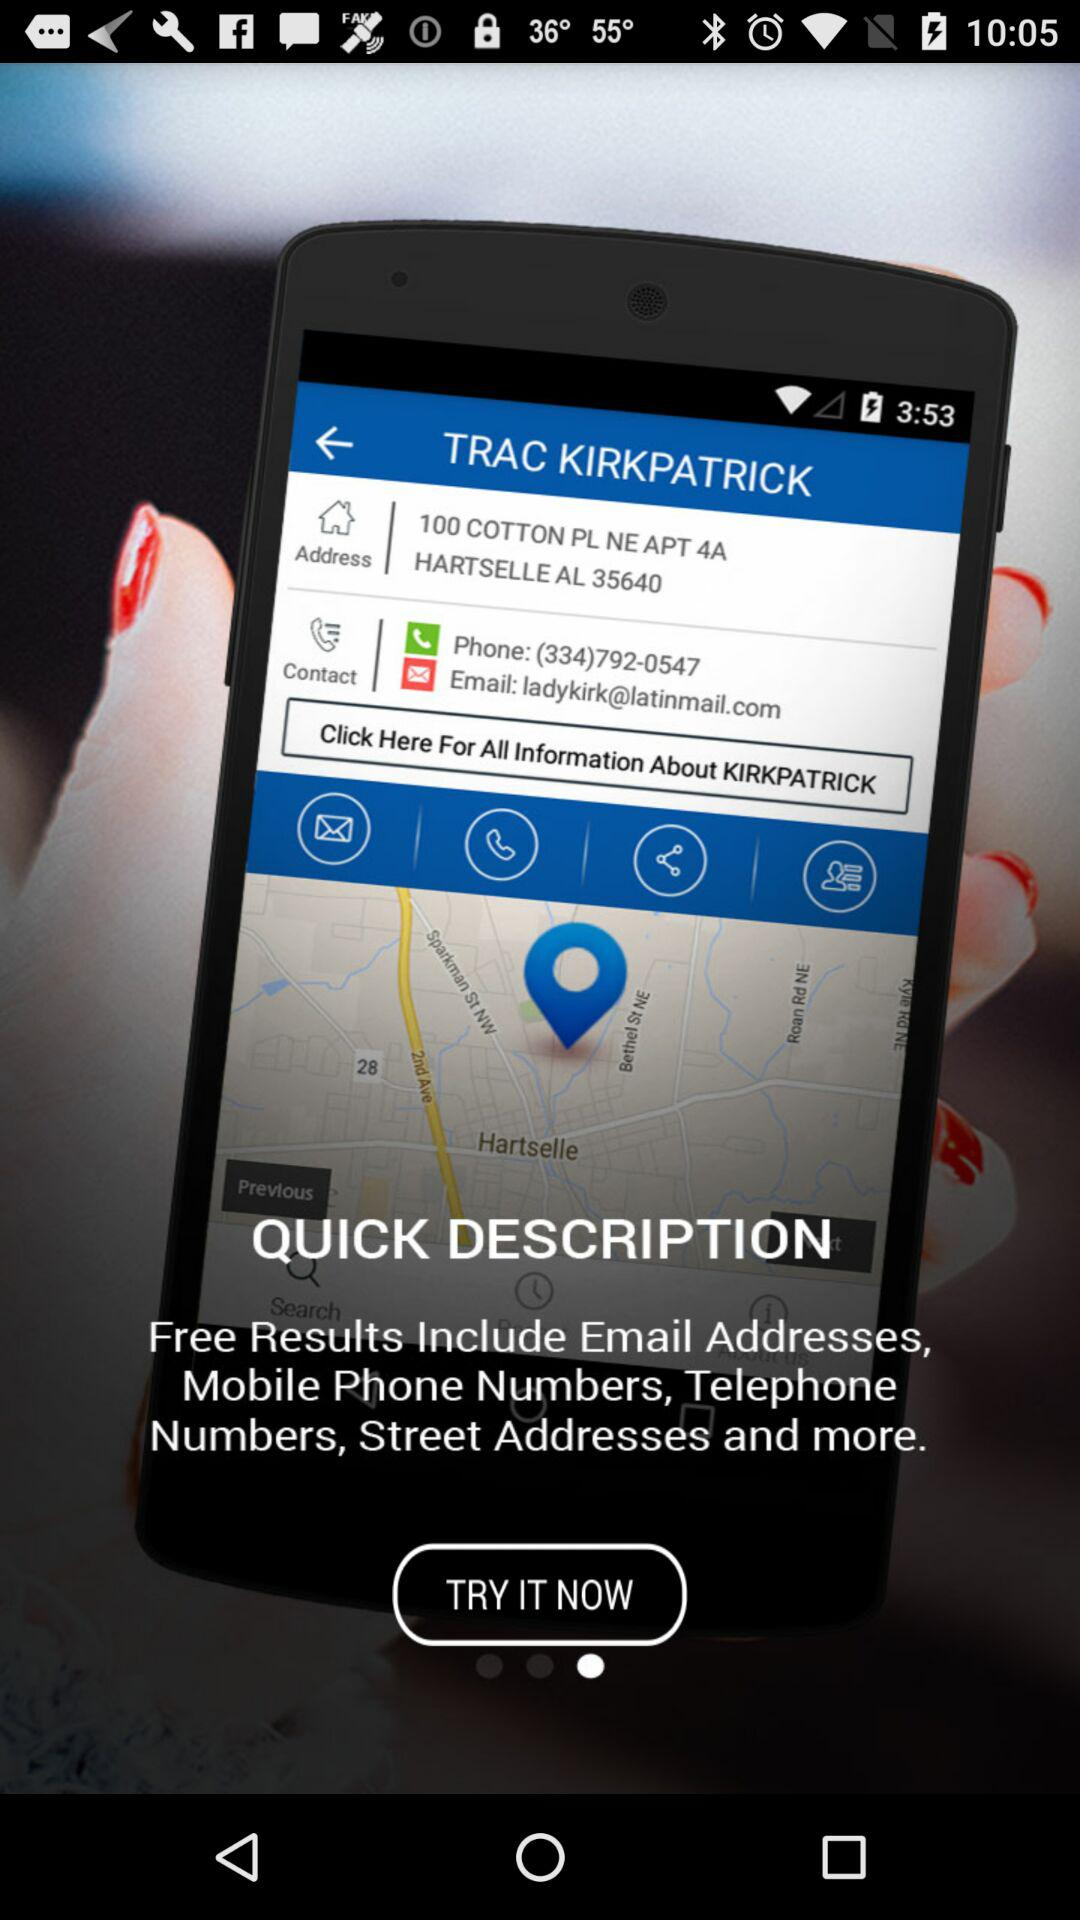What is the application name?
When the provided information is insufficient, respond with <no answer>. <no answer> 